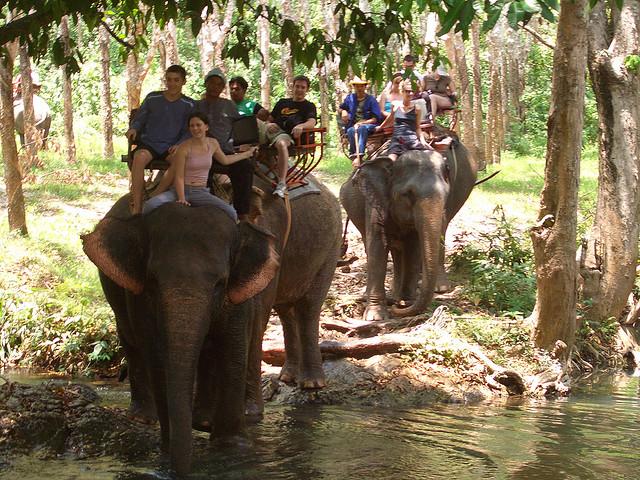Are they playing basketball?
Short answer required. No. How many elephants are in the water?
Answer briefly. 1. How many animals can be seen?
Quick response, please. 3. What are these people riding?
Keep it brief. Elephants. What is one advantage to the humans riding these animals over riding a horse?
Concise answer only. More people fit per animal. 